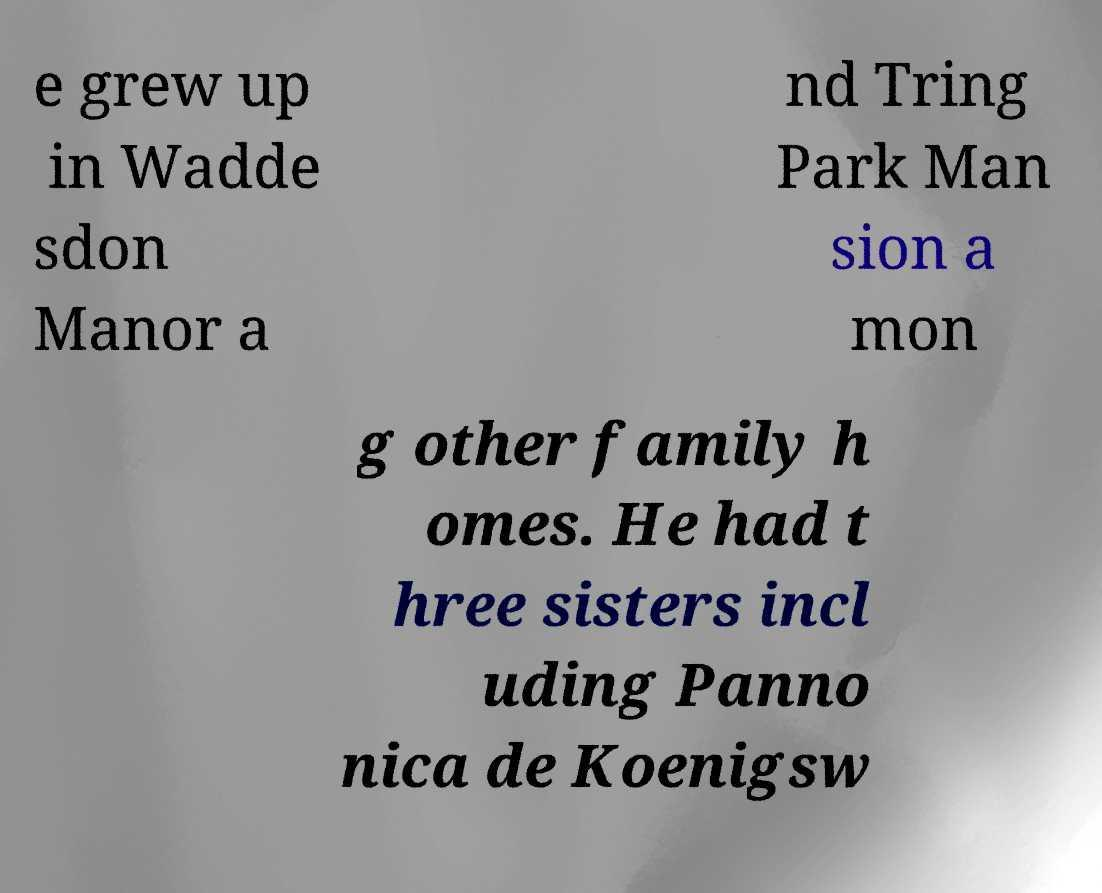Could you assist in decoding the text presented in this image and type it out clearly? e grew up in Wadde sdon Manor a nd Tring Park Man sion a mon g other family h omes. He had t hree sisters incl uding Panno nica de Koenigsw 